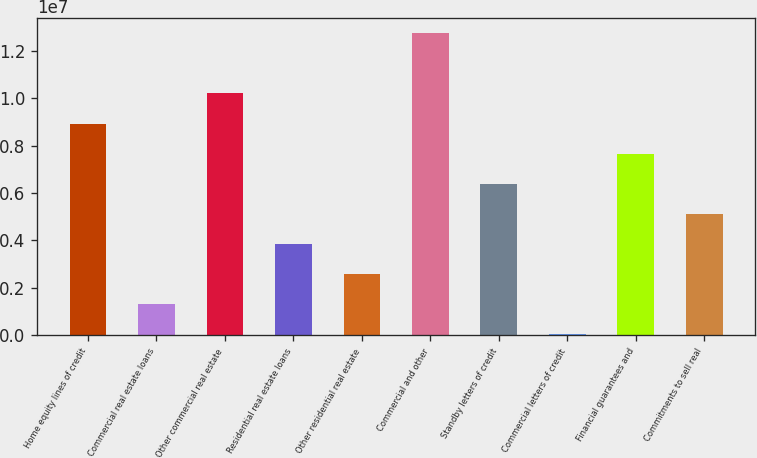Convert chart to OTSL. <chart><loc_0><loc_0><loc_500><loc_500><bar_chart><fcel>Home equity lines of credit<fcel>Commercial real estate loans<fcel>Other commercial real estate<fcel>Residential real estate loans<fcel>Other residential real estate<fcel>Commercial and other<fcel>Standby letters of credit<fcel>Commercial letters of credit<fcel>Financial guarantees and<fcel>Commitments to sell real<nl><fcel>8.92769e+06<fcel>1.31545e+06<fcel>1.01964e+07<fcel>3.85286e+06<fcel>2.58415e+06<fcel>1.27338e+07<fcel>6.39028e+06<fcel>46739<fcel>7.65898e+06<fcel>5.12157e+06<nl></chart> 